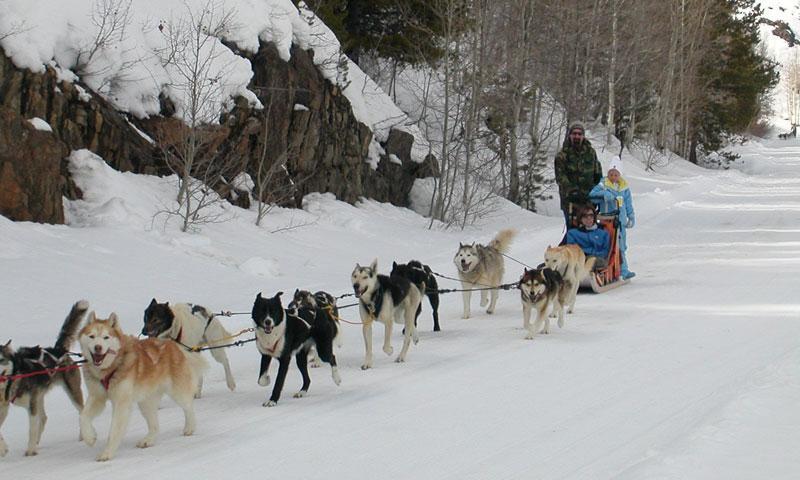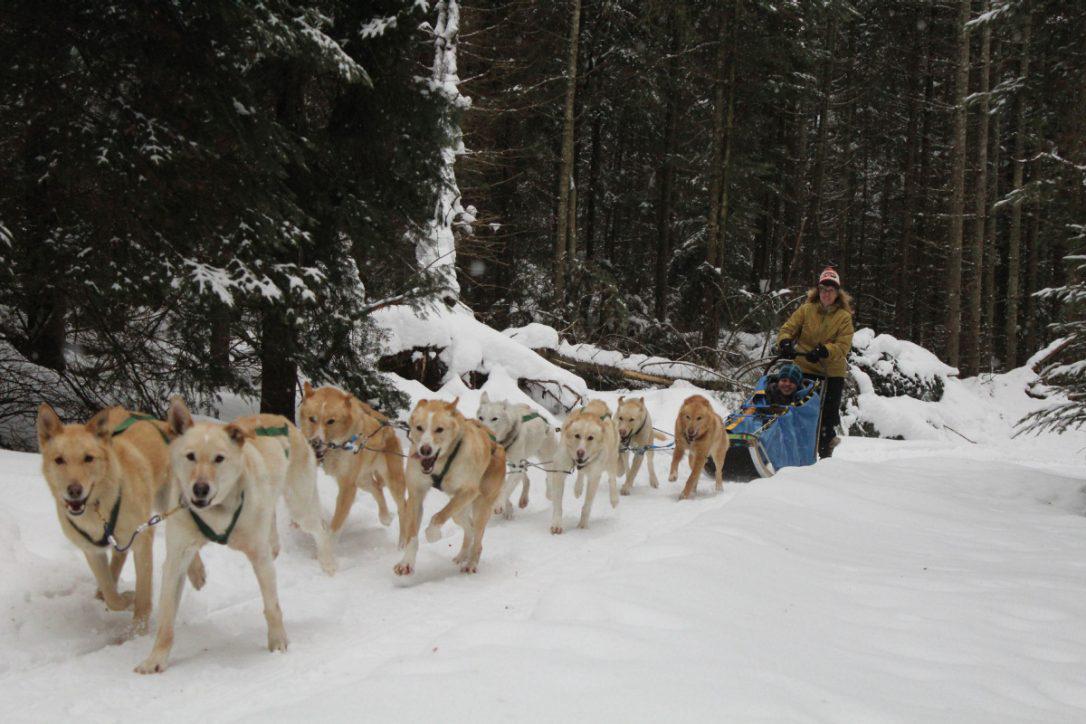The first image is the image on the left, the second image is the image on the right. Analyze the images presented: Is the assertion "The dog-pulled sleds in the left and right images move forward over snow at a leftward angle." valid? Answer yes or no. Yes. The first image is the image on the left, the second image is the image on the right. For the images shown, is this caption "All the dogs are moving forward." true? Answer yes or no. Yes. 